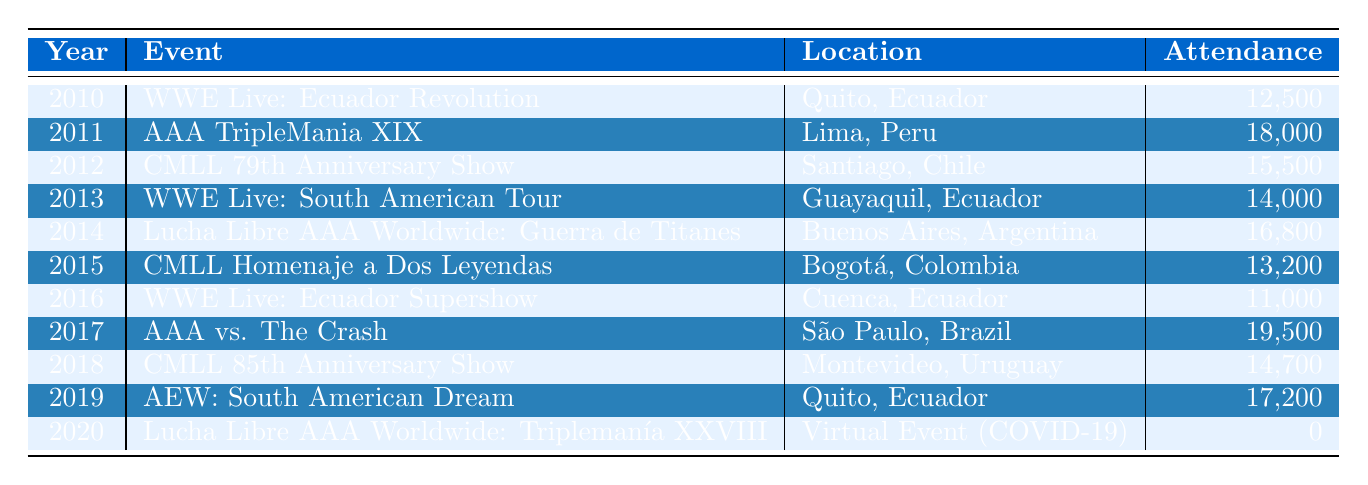What was the attendance for the event in 2017? Referring to the table in 2017, the event listed is "AAA vs. The Crash" and the attendance is noted as 19,500.
Answer: 19,500 Which event had the highest attendance between 2010 and 2019? By examining the attendance figures for each event from 2010 to 2019, "AAA vs. The Crash" in 2017 has the highest figure at 19,500.
Answer: 19,500 Did any event in 2020 have an attendance figure above zero? Looking at the 2020 entry, the event "Lucha Libre AAA Worldwide: Triplemanía XXVIII" shows an attendance of 0, indicating no events had an attendance figure above zero in that year.
Answer: No What is the average attendance for all events in Ecuador from 2010 to 2020? The events occurring in Ecuador are: 12,500 (2010), 14,000 (2013), 11,000 (2016), and 17,200 (2019). The total attendance for these events is 54,700, and there are 4 events, so the average is 54,700 / 4 = 13,675.
Answer: 13,675 What is the difference in attendance between the highest and lowest attended events? The highest attendance is 19,500 (2017) and the lowest is 0 (2020). The difference is 19,500 - 0 = 19,500.
Answer: 19,500 Which country hosted the CMLL 79th Anniversary Show? The table indicates that the CMLL 79th Anniversary Show took place in Santiago, Chile.
Answer: Chile In which year did Ecuador host the least amount of wrestling event attendance? The table shows "WWE Live: Ecuador Supershow" in 2016 had the lowest attendance for events in Ecuador, with a figure of 11,000.
Answer: 2016 How many events had an attendance of 15,000 or more? By reviewing the attendance figures, the events with 15,000 or more are: 18,000 (2011), 15,500 (2012), 16,800 (2014), 19,500 (2017), and 17,200 (2019), totaling 5 events.
Answer: 5 What was the average attendance of wrestling events in South America between 2010 and 2020? Summing the attendances: 12,500 + 18,000 + 15,500 + 14,000 + 16,800 + 13,200 + 11,000 + 19,500 + 14,700 + 17,200 + 0 = 127,900. There are 11 events, so the average is 127,900 / 11 = about 11,545.45, approximating to 11,545.
Answer: 11,545 Was there an event in Lima, Peru with attendance above 15,000? The table shows the event "AAA TripleMania XIX" in 2011 had an attendance of 18,000, which is above 15,000.
Answer: Yes 